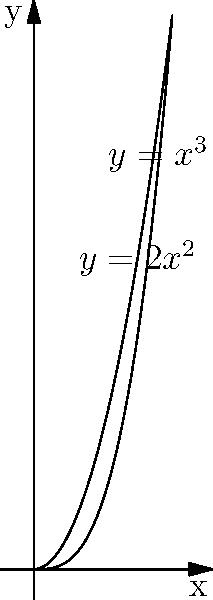A lamina is bounded by the curves $y=2x^2$ and $y=x^3$ from $x=0$ to $x=2$. The density at any point $(x,y)$ is given by $\rho(x,y) = x + y$. Find the x-coordinate of the center of mass of this lamina. To find the x-coordinate of the center of mass, we need to follow these steps:

1) First, we need to set up the integrals for the mass and the moment about the y-axis:

   Mass: $M = \int\int_R \rho(x,y) dA$
   Moment: $M_y = \int\int_R x\rho(x,y) dA$

2) The region R is bounded by $y=2x^2$ and $y=x^3$ from $x=0$ to $x=2$. We'll integrate with respect to y first, then x.

3) Set up the double integrals:

   $M = \int_0^2 \int_{2x^2}^{x^3} (x+y) dy dx$
   $M_y = \int_0^2 \int_{2x^2}^{x^3} x(x+y) dy dx$

4) Evaluate the inner integrals:

   $M = \int_0^2 [xy + \frac{1}{2}y^2]_{2x^2}^{x^3} dx$
      $= \int_0^2 [(x^4 + \frac{1}{2}x^6) - (2x^3 + 2x^4)] dx$
      $= \int_0^2 (\frac{1}{2}x^6 - 2x^3 - x^4) dx$

   $M_y = \int_0^2 [x^2y + \frac{1}{2}xy^2]_{2x^2}^{x^3} dx$
        $= \int_0^2 [(x^5 + \frac{1}{2}x^7) - (2x^5 + 2x^5)] dx$
        $= \int_0^2 (\frac{1}{2}x^7 - 3x^5) dx$

5) Evaluate the outer integrals:

   $M = [\frac{1}{14}x^7 - \frac{1}{2}x^4 - \frac{1}{5}x^5]_0^2$
      $= \frac{1}{14}(2^7) - \frac{1}{2}(2^4) - \frac{1}{5}(2^5)$
      $= \frac{128}{14} - 8 - \frac{32}{5} = \frac{128}{14} - \frac{40}{5} - \frac{32}{5} = \frac{128}{14} - \frac{72}{5}$

   $M_y = [\frac{1}{16}x^8 - \frac{1}{2}x^6]_0^2$
        $= \frac{1}{16}(2^8) - \frac{1}{2}(2^6)$
        $= 16 - 32 = -16$

6) The x-coordinate of the center of mass is given by:

   $\bar{x} = \frac{M_y}{M} = \frac{-16}{\frac{128}{14} - \frac{72}{5}}$

7) Simplify this fraction to get the final answer.
Answer: $\bar{x} = \frac{-80}{9 + \frac{14}{5}}$ 